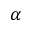<formula> <loc_0><loc_0><loc_500><loc_500>\alpha</formula> 